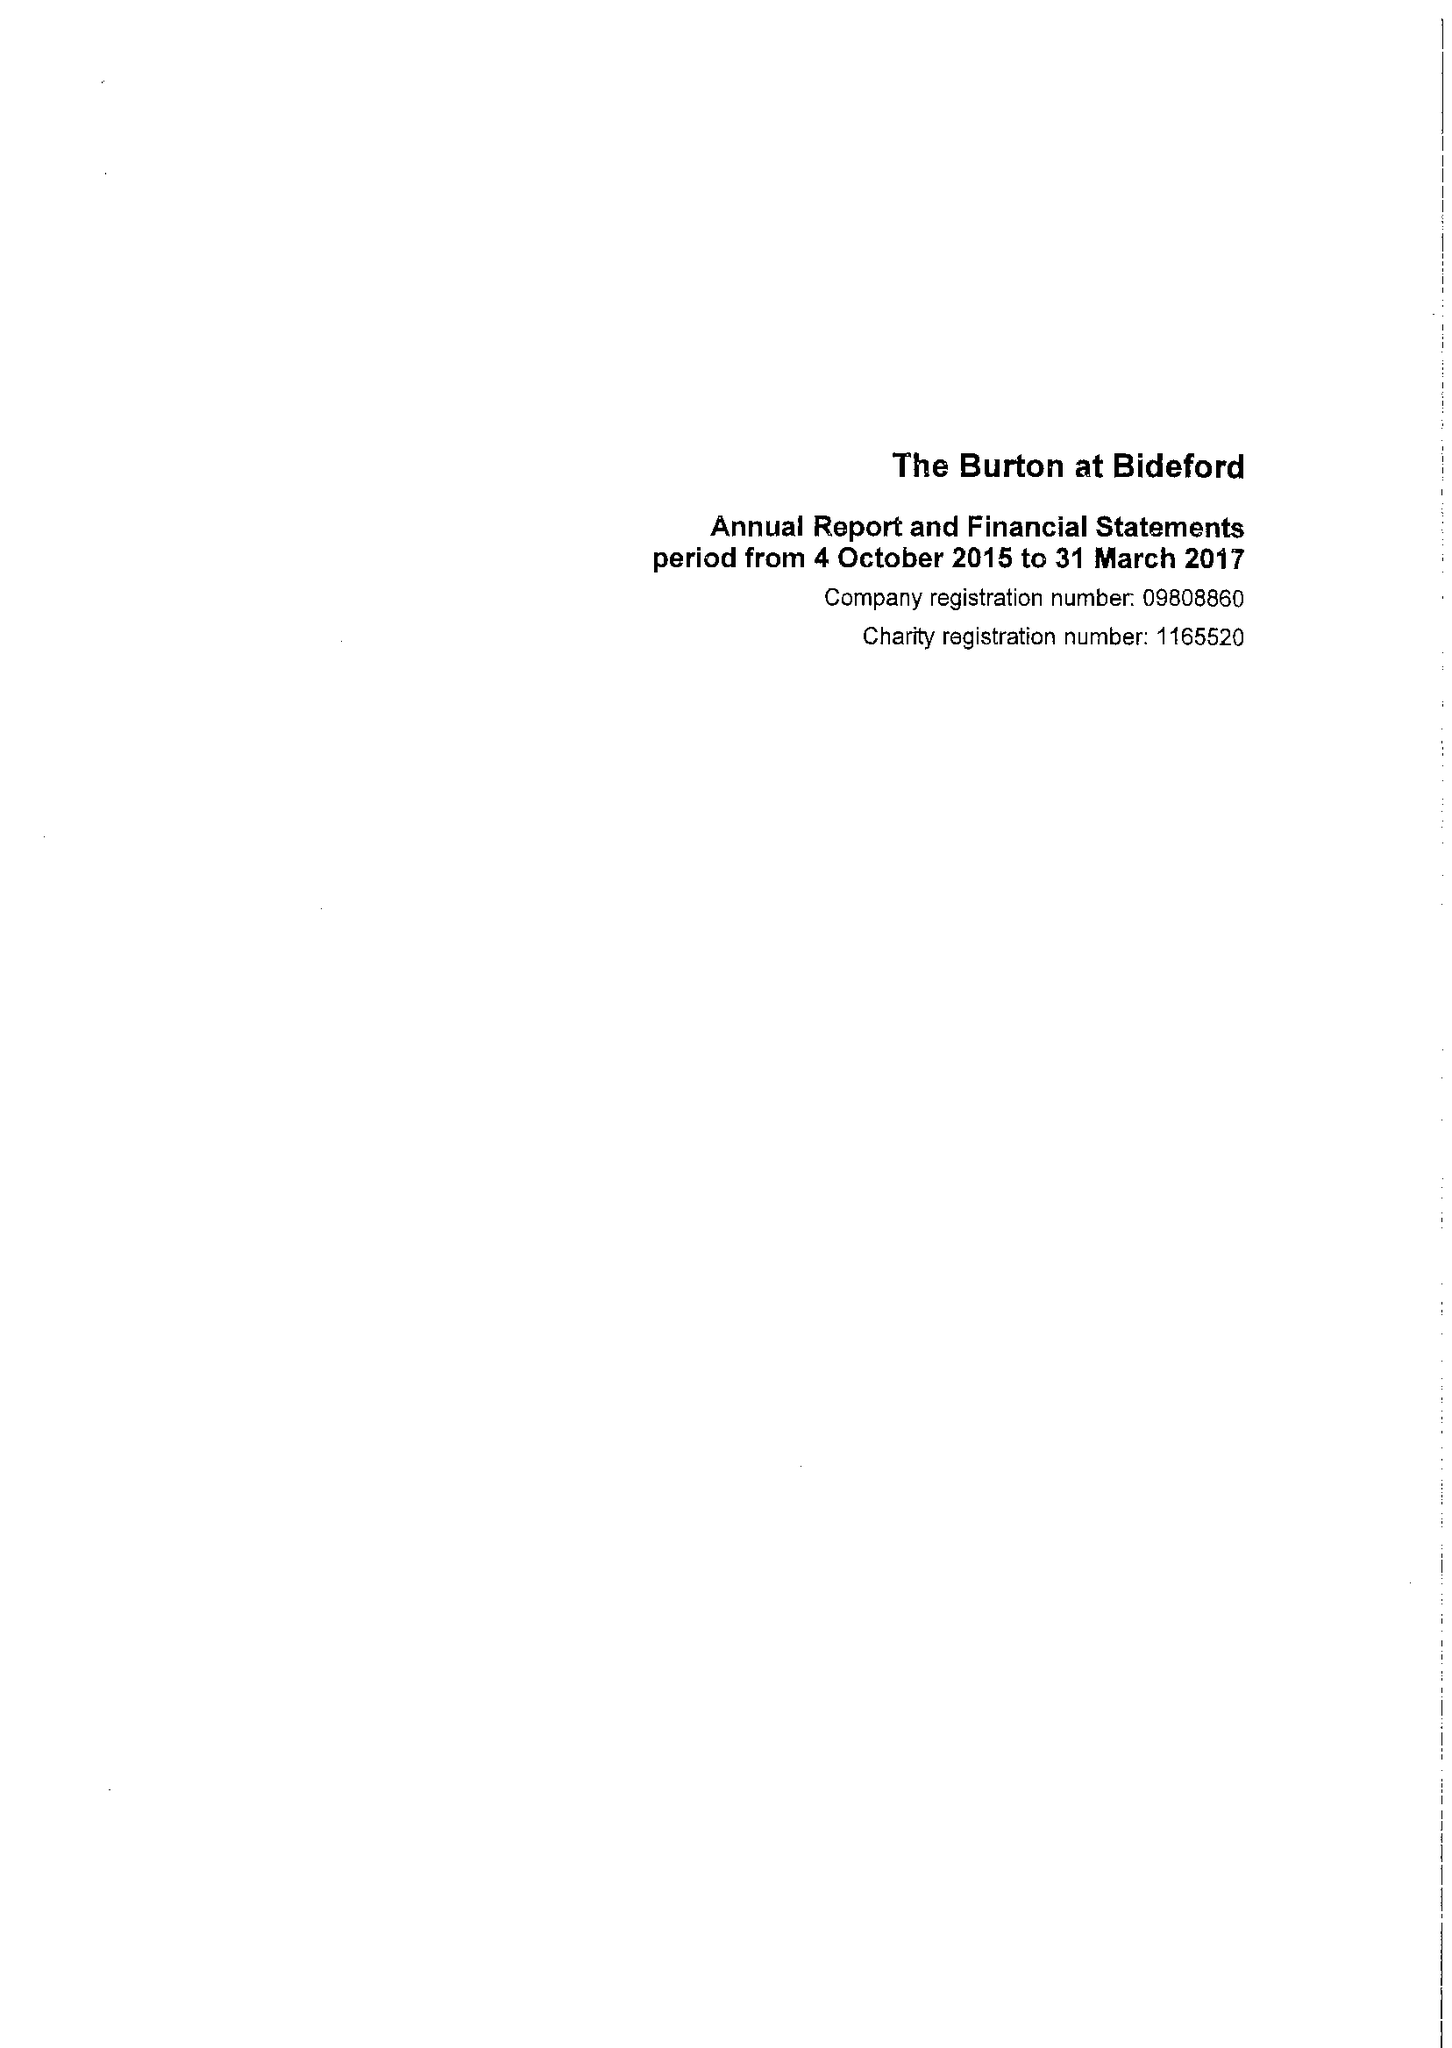What is the value for the address__street_line?
Answer the question using a single word or phrase. KINGSLEY ROAD 